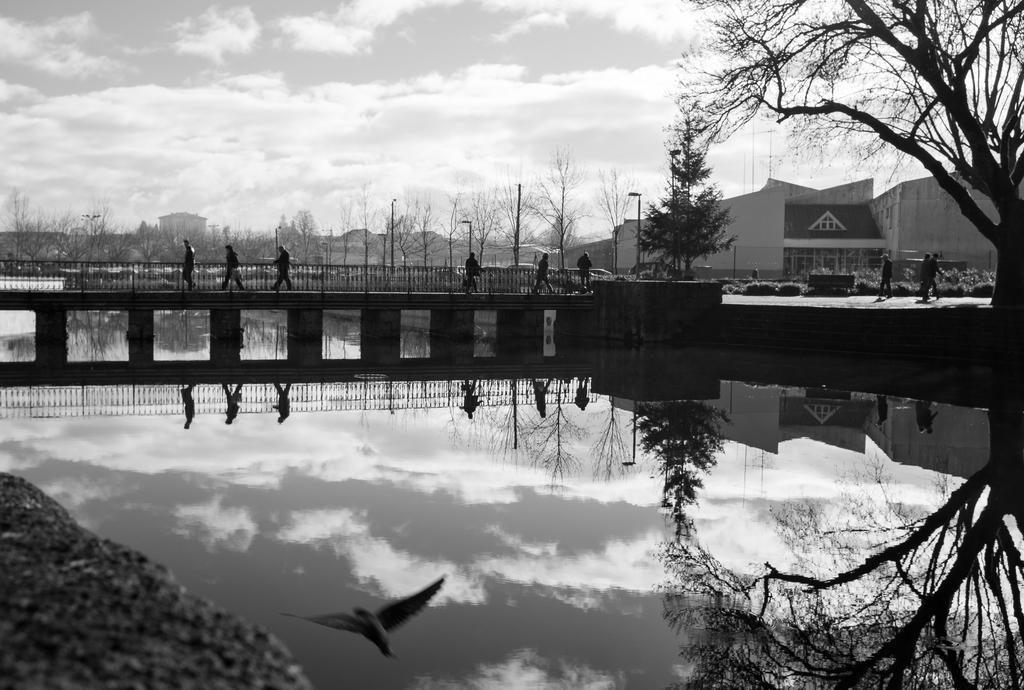How would you summarize this image in a sentence or two? It is a black and white image and in this image we can see the bridge and on the bridge we can see few people walking. Image also consists of buildings. At the top there is a cloudy sky and at the bottom we can see the water. Bird is also visible in this image. 